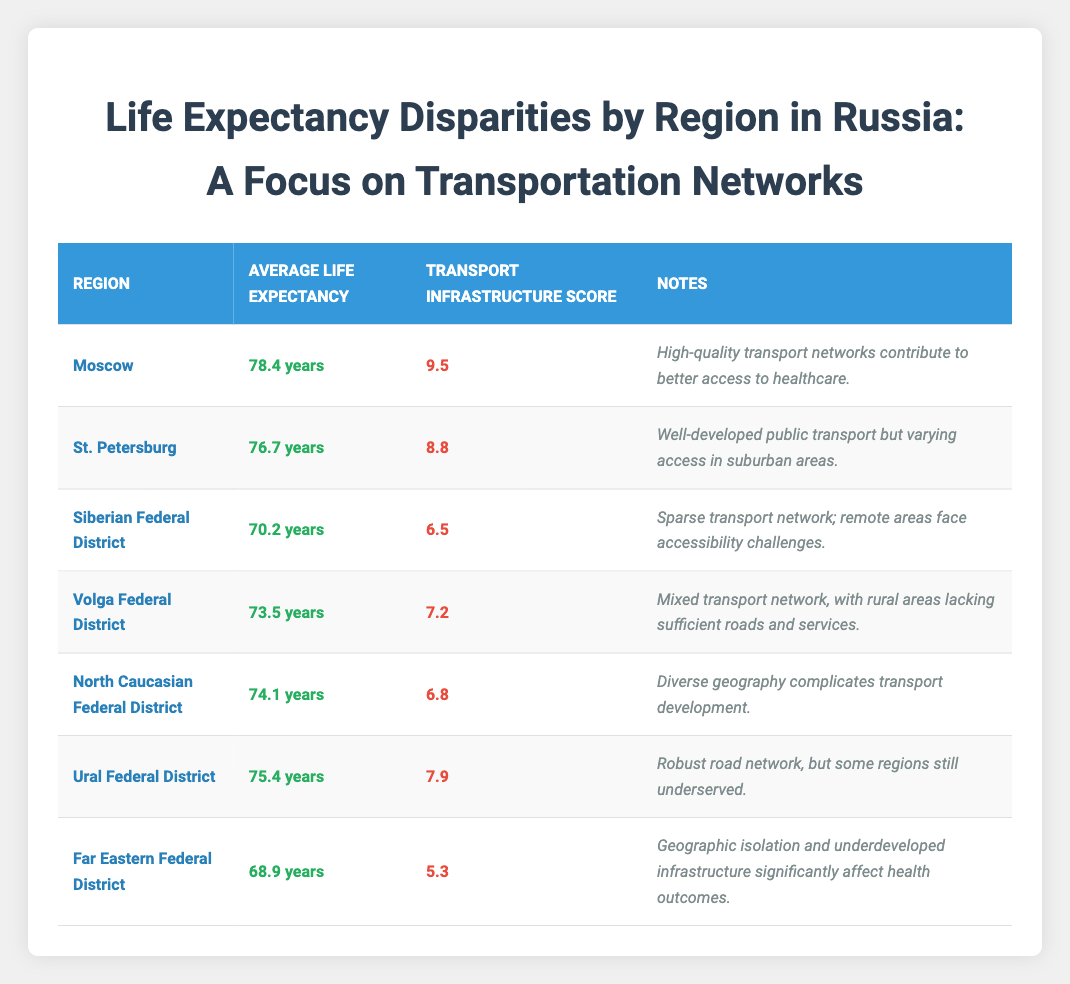What is the average life expectancy in Moscow? According to the table, the average life expectancy for the region of Moscow is listed as 78.4 years.
Answer: 78.4 years Which region has the lowest transport infrastructure score? By looking at the transport infrastructure scores in the table, Far Eastern Federal District has the lowest score at 5.3.
Answer: 5.3 Is the average life expectancy in the Siberian Federal District higher than in the Ural Federal District? The average life expectancy in the Siberian Federal District is 70.2 years, while in the Ural Federal District, it is 75.4 years. Since 70.2 is less than 75.4, the answer is no.
Answer: No What is the difference in average life expectancy between Moscow and Far Eastern Federal District? The average life expectancy for Moscow is 78.4 years and for Far Eastern Federal District it is 68.9 years. To find the difference, subtract: 78.4 - 68.9 = 9.5 years.
Answer: 9.5 years How does the average life expectancy change from the Far Eastern Federal District to the Volga Federal District? The Far Eastern Federal District's average life expectancy is 68.9 years and the Volga Federal District's is 73.5 years. The change is calculated by subtracting: 73.5 - 68.9 = 4.6 years, indicating an increase of 4.6 years.
Answer: 4.6 years Which region has a life expectancy closest to the national average? First, find the life expectancies: 78.4 (Moscow), 76.7 (St. Petersburg), 70.2 (Siberian), 73.5 (Volga), 74.1 (North Caucasian), 75.4 (Ural), 68.9 (Far Eastern). There isn't a provided national average in the table, but the Volga Federal District at 73.5 years is nearest to the average of the other values listed.
Answer: Volga Federal District Does St. Petersburg have a higher average life expectancy than the North Caucasian Federal District? St. Petersburg's average life expectancy is 76.7 years, and the North Caucasian Federal District is 74.1 years. Therefore, since 76.7 is greater than 74.1, the statement is true.
Answer: Yes In terms of transport infrastructure, which region has the highest score and what is that score? The highest transport infrastructure score from the table belongs to Moscow, with a score of 9.5.
Answer: 9.5 